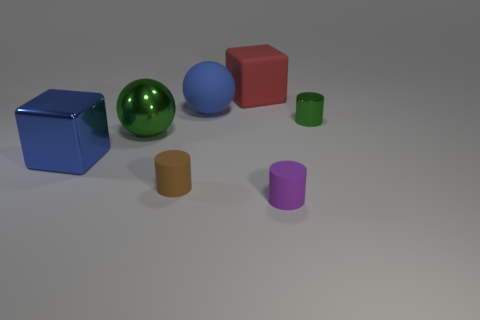How many red things are either large blocks or big shiny objects?
Offer a very short reply. 1. There is a cylinder that is made of the same material as the blue cube; what color is it?
Your answer should be very brief. Green. Is there anything else that has the same size as the blue shiny block?
Offer a terse response. Yes. How many tiny objects are either blue things or blue cubes?
Make the answer very short. 0. Is the number of tiny brown matte cylinders less than the number of purple metal objects?
Your answer should be very brief. No. There is a big metal thing that is the same shape as the large blue matte thing; what color is it?
Provide a short and direct response. Green. Is there any other thing that has the same shape as the red object?
Make the answer very short. Yes. Are there more cylinders than big red cubes?
Provide a succinct answer. Yes. How many other objects are there of the same material as the tiny brown cylinder?
Ensure brevity in your answer.  3. There is a matte thing that is in front of the rubber cylinder that is behind the matte thing right of the rubber block; what shape is it?
Offer a terse response. Cylinder. 